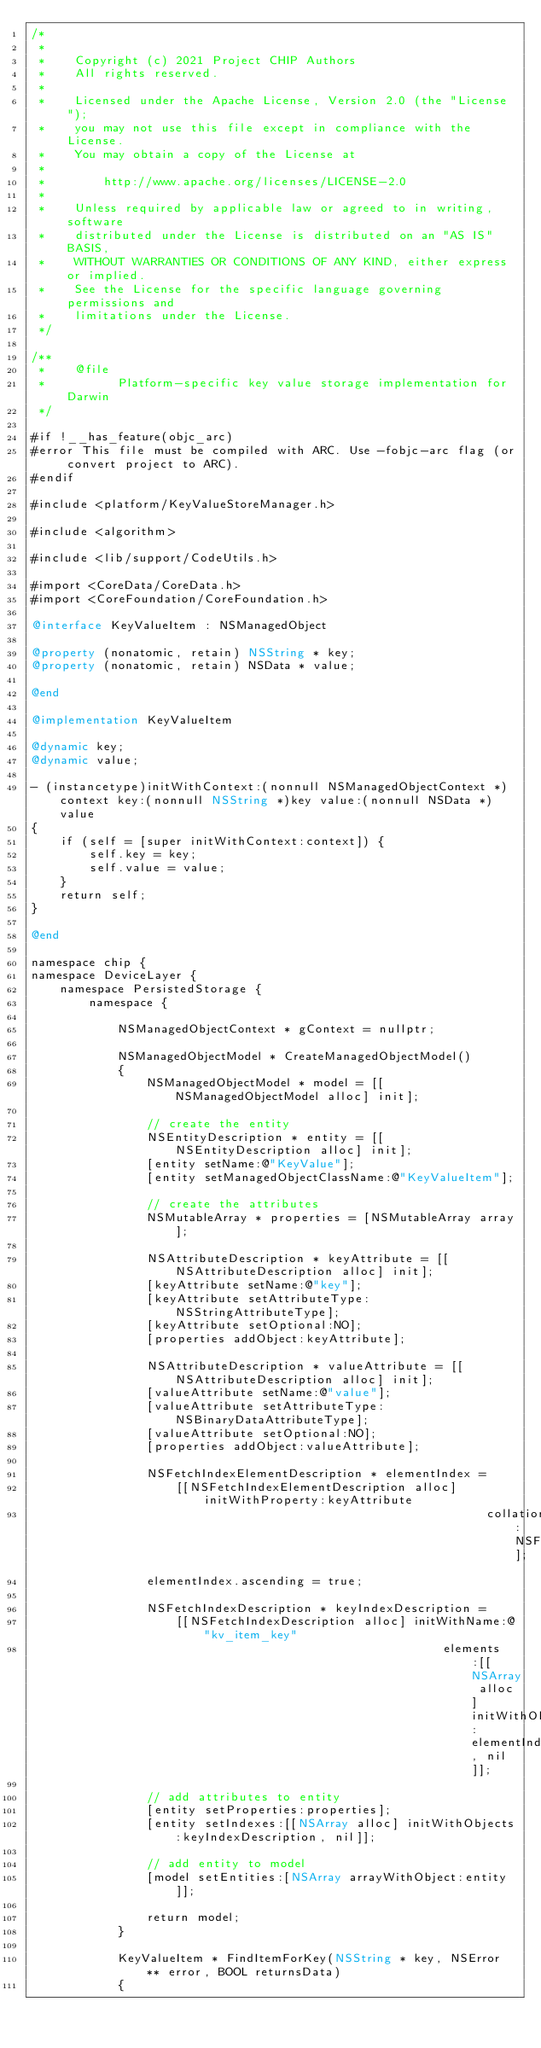<code> <loc_0><loc_0><loc_500><loc_500><_ObjectiveC_>/*
 *
 *    Copyright (c) 2021 Project CHIP Authors
 *    All rights reserved.
 *
 *    Licensed under the Apache License, Version 2.0 (the "License");
 *    you may not use this file except in compliance with the License.
 *    You may obtain a copy of the License at
 *
 *        http://www.apache.org/licenses/LICENSE-2.0
 *
 *    Unless required by applicable law or agreed to in writing, software
 *    distributed under the License is distributed on an "AS IS" BASIS,
 *    WITHOUT WARRANTIES OR CONDITIONS OF ANY KIND, either express or implied.
 *    See the License for the specific language governing permissions and
 *    limitations under the License.
 */

/**
 *    @file
 *          Platform-specific key value storage implementation for Darwin
 */

#if !__has_feature(objc_arc)
#error This file must be compiled with ARC. Use -fobjc-arc flag (or convert project to ARC).
#endif

#include <platform/KeyValueStoreManager.h>

#include <algorithm>

#include <lib/support/CodeUtils.h>

#import <CoreData/CoreData.h>
#import <CoreFoundation/CoreFoundation.h>

@interface KeyValueItem : NSManagedObject

@property (nonatomic, retain) NSString * key;
@property (nonatomic, retain) NSData * value;

@end

@implementation KeyValueItem

@dynamic key;
@dynamic value;

- (instancetype)initWithContext:(nonnull NSManagedObjectContext *)context key:(nonnull NSString *)key value:(nonnull NSData *)value
{
    if (self = [super initWithContext:context]) {
        self.key = key;
        self.value = value;
    }
    return self;
}

@end

namespace chip {
namespace DeviceLayer {
    namespace PersistedStorage {
        namespace {

            NSManagedObjectContext * gContext = nullptr;

            NSManagedObjectModel * CreateManagedObjectModel()
            {
                NSManagedObjectModel * model = [[NSManagedObjectModel alloc] init];

                // create the entity
                NSEntityDescription * entity = [[NSEntityDescription alloc] init];
                [entity setName:@"KeyValue"];
                [entity setManagedObjectClassName:@"KeyValueItem"];

                // create the attributes
                NSMutableArray * properties = [NSMutableArray array];

                NSAttributeDescription * keyAttribute = [[NSAttributeDescription alloc] init];
                [keyAttribute setName:@"key"];
                [keyAttribute setAttributeType:NSStringAttributeType];
                [keyAttribute setOptional:NO];
                [properties addObject:keyAttribute];

                NSAttributeDescription * valueAttribute = [[NSAttributeDescription alloc] init];
                [valueAttribute setName:@"value"];
                [valueAttribute setAttributeType:NSBinaryDataAttributeType];
                [valueAttribute setOptional:NO];
                [properties addObject:valueAttribute];

                NSFetchIndexElementDescription * elementIndex =
                    [[NSFetchIndexElementDescription alloc] initWithProperty:keyAttribute
                                                               collationType:NSFetchIndexElementTypeBinary];
                elementIndex.ascending = true;

                NSFetchIndexDescription * keyIndexDescription =
                    [[NSFetchIndexDescription alloc] initWithName:@"kv_item_key"
                                                         elements:[[NSArray alloc] initWithObjects:elementIndex, nil]];

                // add attributes to entity
                [entity setProperties:properties];
                [entity setIndexes:[[NSArray alloc] initWithObjects:keyIndexDescription, nil]];

                // add entity to model
                [model setEntities:[NSArray arrayWithObject:entity]];

                return model;
            }

            KeyValueItem * FindItemForKey(NSString * key, NSError ** error, BOOL returnsData)
            {</code> 